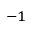<formula> <loc_0><loc_0><loc_500><loc_500>^ { - 1 }</formula> 